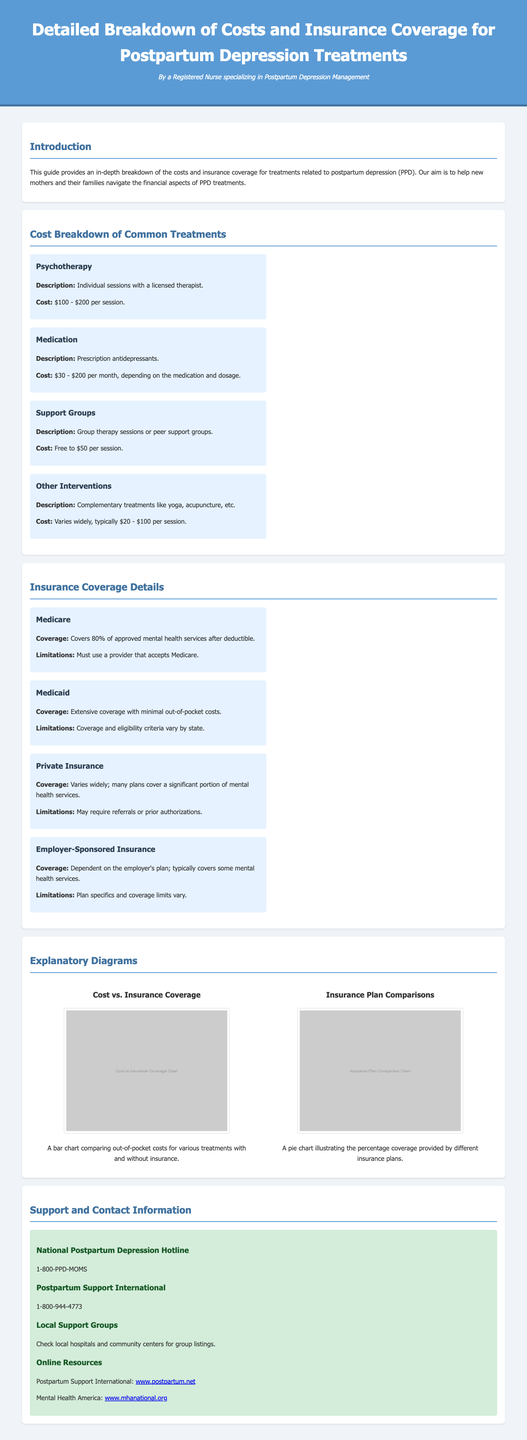what is the cost range for psychotherapy? The document states that the cost for psychotherapy ranges from $100 to $200 per session.
Answer: $100 - $200 per session what percentage of mental health services does Medicare cover after the deductible? The document indicates that Medicare covers 80% of approved mental health services after the deductible.
Answer: 80% what is the contact number for the National Postpartum Depression Hotline? The document provides the number for the National Postpartum Depression Hotline as 1-800-PPD-MOMS.
Answer: 1-800-PPD-MOMS what treatments are considered "Other Interventions"? The document describes "Other Interventions" as complementary treatments like yoga and acupuncture.
Answer: Yoga, acupuncture which insurance provides extensive coverage with minimal out-of-pocket costs? The document specifies Medicaid as the insurance that provides extensive coverage with minimal out-of-pocket costs.
Answer: Medicaid what is the coverage limitation for private insurance? The document states that private insurance coverage may require referrals or prior authorizations.
Answer: Referrals or prior authorizations how much can group therapy sessions cost? The document indicates that group therapy sessions or peer support groups can cost from free to $50 per session.
Answer: Free to $50 per session how are costs for medication categorized in the document? The document categorizes costs for medication as ranging from $30 to $200 per month, depending on the medication and dosage.
Answer: $30 - $200 per month what type of insurance coverage is dependent on the employer's plan? The document describes Employer-Sponsored Insurance as coverage that depends on the employer's plan.
Answer: Employer-Sponsored Insurance 